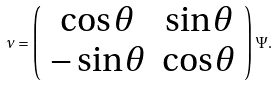<formula> <loc_0><loc_0><loc_500><loc_500>\nu = \left ( \begin{array} { c c } \cos \theta & \sin \theta \\ - \sin \theta & \cos \theta \end{array} \right ) \Psi .</formula> 